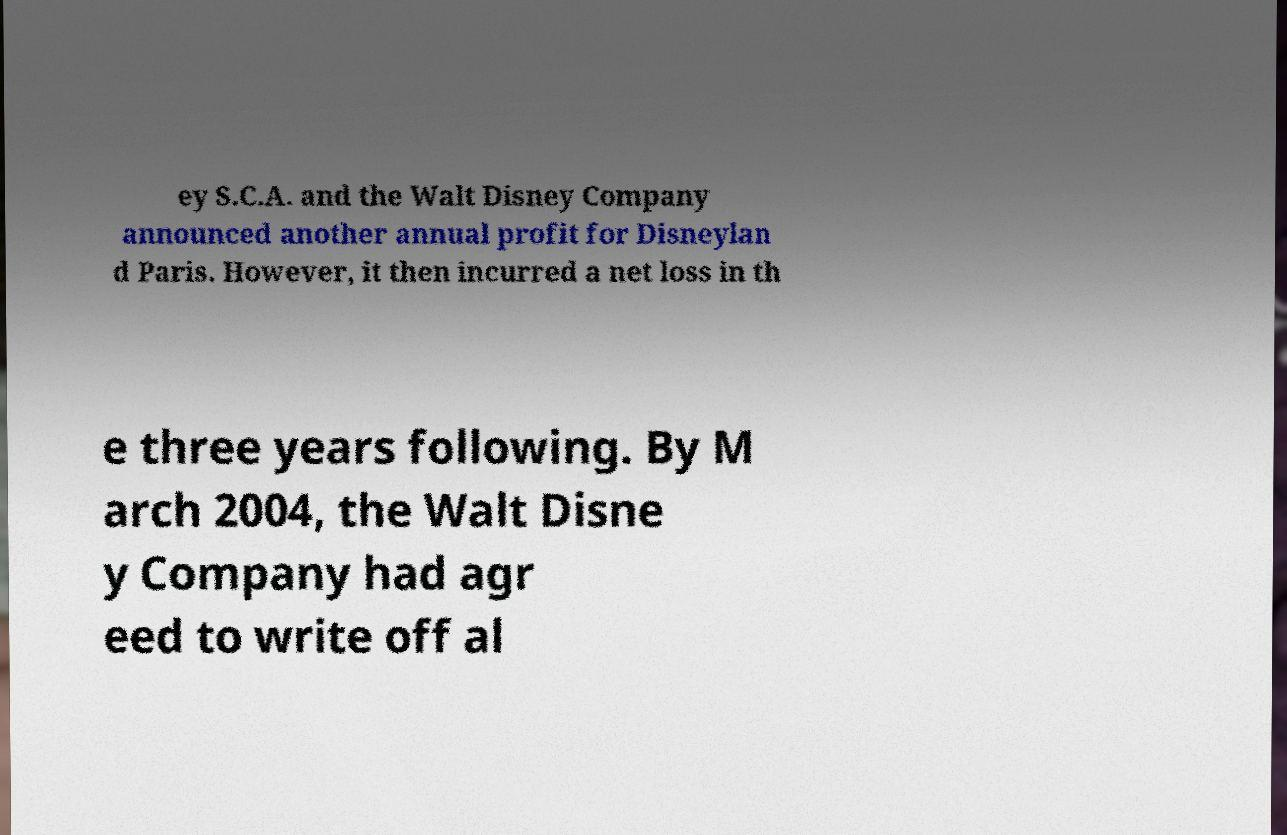Please identify and transcribe the text found in this image. ey S.C.A. and the Walt Disney Company announced another annual profit for Disneylan d Paris. However, it then incurred a net loss in th e three years following. By M arch 2004, the Walt Disne y Company had agr eed to write off al 